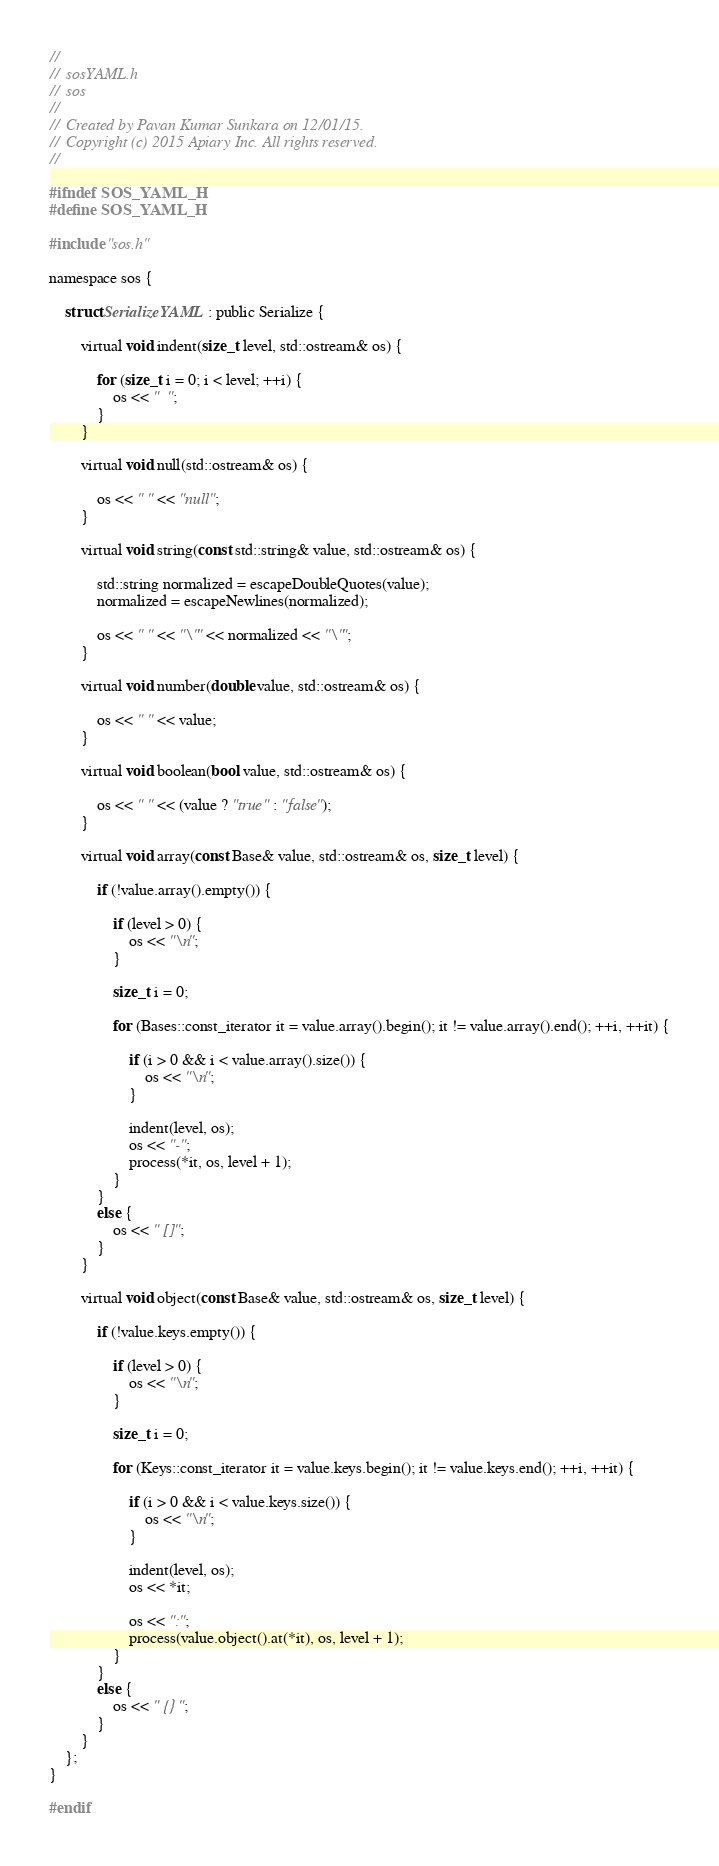<code> <loc_0><loc_0><loc_500><loc_500><_C_>//
//  sosYAML.h
//  sos
//
//  Created by Pavan Kumar Sunkara on 12/01/15.
//  Copyright (c) 2015 Apiary Inc. All rights reserved.
//

#ifndef SOS_YAML_H
#define SOS_YAML_H

#include "sos.h"

namespace sos {

    struct SerializeYAML : public Serialize {

        virtual void indent(size_t level, std::ostream& os) {

            for (size_t i = 0; i < level; ++i) {
                os << "  ";
            }
        }

        virtual void null(std::ostream& os) {

            os << " " << "null";
        }

        virtual void string(const std::string& value, std::ostream& os) {

            std::string normalized = escapeDoubleQuotes(value);
            normalized = escapeNewlines(normalized);

            os << " " << "\"" << normalized << "\"";
        }

        virtual void number(double value, std::ostream& os) {

            os << " " << value;
        }

        virtual void boolean(bool value, std::ostream& os) {

            os << " " << (value ? "true" : "false");
        }

        virtual void array(const Base& value, std::ostream& os, size_t level) {

            if (!value.array().empty()) {

                if (level > 0) {
                    os << "\n";
                }

                size_t i = 0;

                for (Bases::const_iterator it = value.array().begin(); it != value.array().end(); ++i, ++it) {

                    if (i > 0 && i < value.array().size()) {
                        os << "\n";
                    }

                    indent(level, os);
                    os << "-";
                    process(*it, os, level + 1);
                }
            }
            else {
                os << " []";
            }
        }

        virtual void object(const Base& value, std::ostream& os, size_t level) {

            if (!value.keys.empty()) {

                if (level > 0) {
                    os << "\n";
                }

                size_t i = 0;

                for (Keys::const_iterator it = value.keys.begin(); it != value.keys.end(); ++i, ++it) {

                    if (i > 0 && i < value.keys.size()) {
                        os << "\n";
                    }
                    
                    indent(level, os);
                    os << *it;
                    
                    os << ":";
                    process(value.object().at(*it), os, level + 1);
                }
            }
            else {
                os << " {}";
            }
        }
    };
}

#endif
</code> 